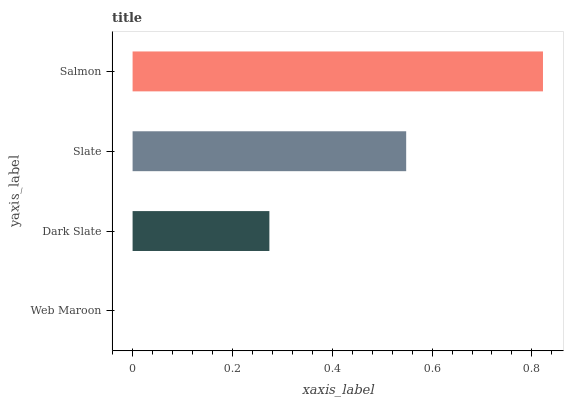Is Web Maroon the minimum?
Answer yes or no. Yes. Is Salmon the maximum?
Answer yes or no. Yes. Is Dark Slate the minimum?
Answer yes or no. No. Is Dark Slate the maximum?
Answer yes or no. No. Is Dark Slate greater than Web Maroon?
Answer yes or no. Yes. Is Web Maroon less than Dark Slate?
Answer yes or no. Yes. Is Web Maroon greater than Dark Slate?
Answer yes or no. No. Is Dark Slate less than Web Maroon?
Answer yes or no. No. Is Slate the high median?
Answer yes or no. Yes. Is Dark Slate the low median?
Answer yes or no. Yes. Is Web Maroon the high median?
Answer yes or no. No. Is Salmon the low median?
Answer yes or no. No. 